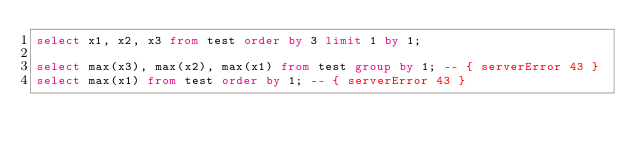<code> <loc_0><loc_0><loc_500><loc_500><_SQL_>select x1, x2, x3 from test order by 3 limit 1 by 1;

select max(x3), max(x2), max(x1) from test group by 1; -- { serverError 43 }
select max(x1) from test order by 1; -- { serverError 43 }


</code> 